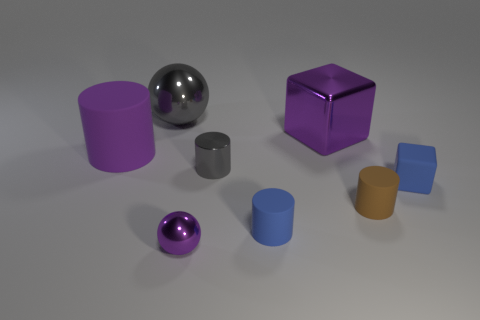Subtract all large purple cylinders. How many cylinders are left? 3 Subtract all purple cubes. How many cubes are left? 1 Add 1 big cylinders. How many objects exist? 9 Subtract 1 balls. How many balls are left? 1 Subtract all cubes. How many objects are left? 6 Subtract all green cylinders. How many gray spheres are left? 1 Add 1 small cylinders. How many small cylinders are left? 4 Add 3 large metal objects. How many large metal objects exist? 5 Subtract 0 red cylinders. How many objects are left? 8 Subtract all brown cylinders. Subtract all cyan balls. How many cylinders are left? 3 